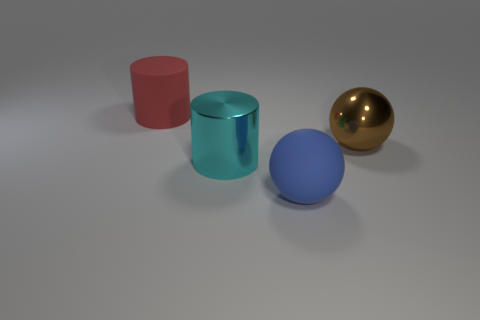What number of other objects are the same shape as the big brown object?
Offer a terse response. 1. Are there any cyan things that have the same material as the big brown sphere?
Make the answer very short. Yes. Does the cylinder behind the big cyan cylinder have the same material as the cylinder that is right of the big red rubber thing?
Provide a short and direct response. No. What number of shiny cylinders are there?
Your answer should be very brief. 1. What shape is the rubber object on the left side of the big matte ball?
Keep it short and to the point. Cylinder. What number of other things are the same size as the cyan thing?
Keep it short and to the point. 3. There is a big rubber thing left of the big cyan metallic cylinder; does it have the same shape as the shiny thing that is on the left side of the brown metallic object?
Make the answer very short. Yes. There is a large blue rubber object; how many metallic balls are left of it?
Provide a succinct answer. 0. What is the color of the sphere that is behind the cyan thing?
Offer a terse response. Brown. What is the color of the other large matte thing that is the same shape as the large brown object?
Offer a very short reply. Blue. 